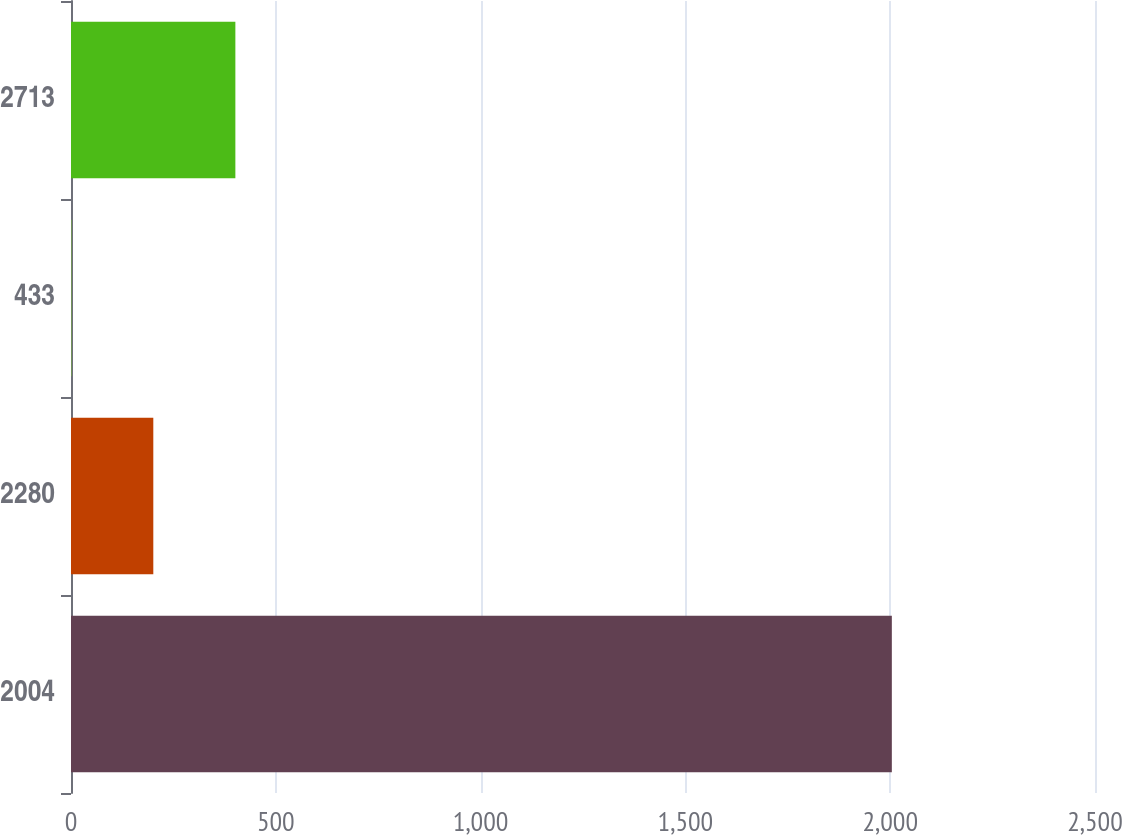<chart> <loc_0><loc_0><loc_500><loc_500><bar_chart><fcel>2004<fcel>2280<fcel>433<fcel>2713<nl><fcel>2004<fcel>200.94<fcel>0.6<fcel>401.28<nl></chart> 